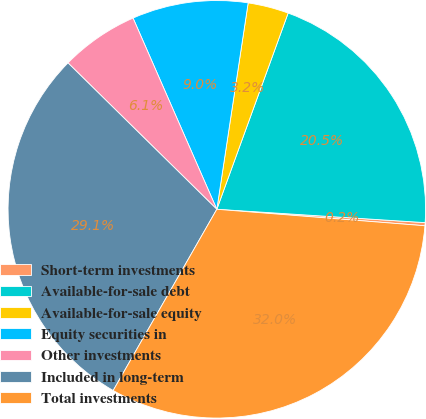Convert chart. <chart><loc_0><loc_0><loc_500><loc_500><pie_chart><fcel>Short-term investments<fcel>Available-for-sale debt<fcel>Available-for-sale equity<fcel>Equity securities in<fcel>Other investments<fcel>Included in long-term<fcel>Total investments<nl><fcel>0.24%<fcel>20.47%<fcel>3.15%<fcel>8.97%<fcel>6.06%<fcel>29.1%<fcel>32.01%<nl></chart> 